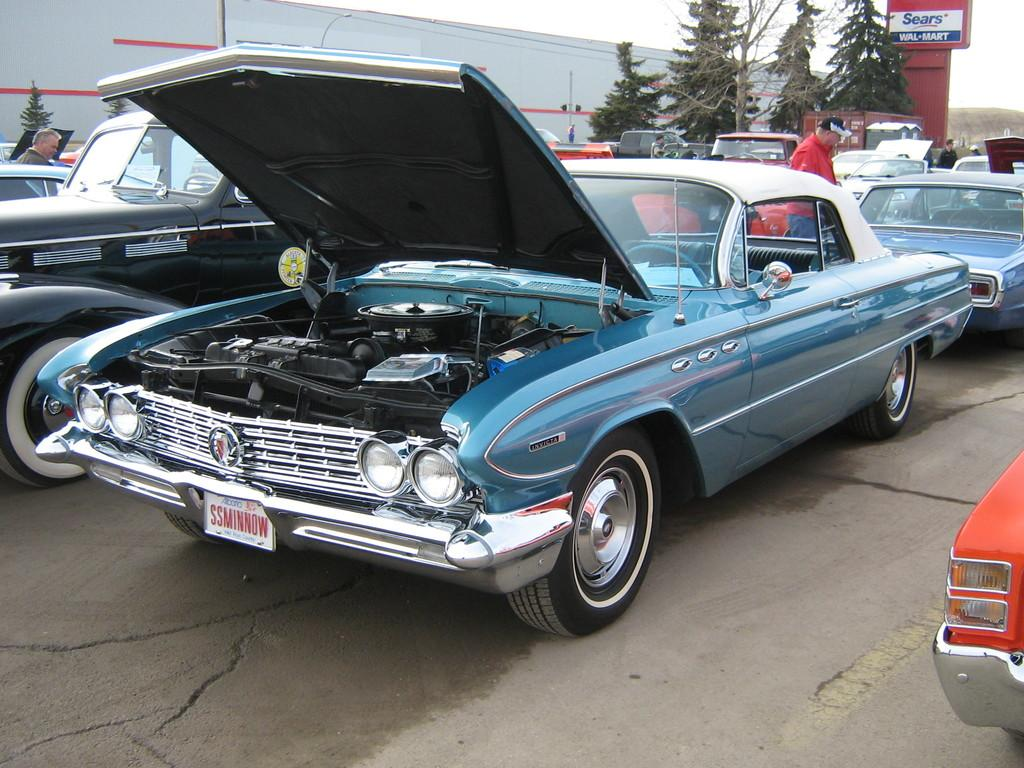What type of vehicles can be seen in the image? There are cars in the image. What are the people on the road doing? There are people standing on the road in the image. What type of vegetation is present in the image? There are trees in the image. What structure can be seen in the image? There is a wall in the image. What is attached to the wall in the image? There is a poster in the image. What is visible in the background of the image? The sky is visible in the background of the image. What type of wren can be seen perched on the sidewalk in the image? There is no wren present in the image, and there is no sidewalk mentioned in the facts. 